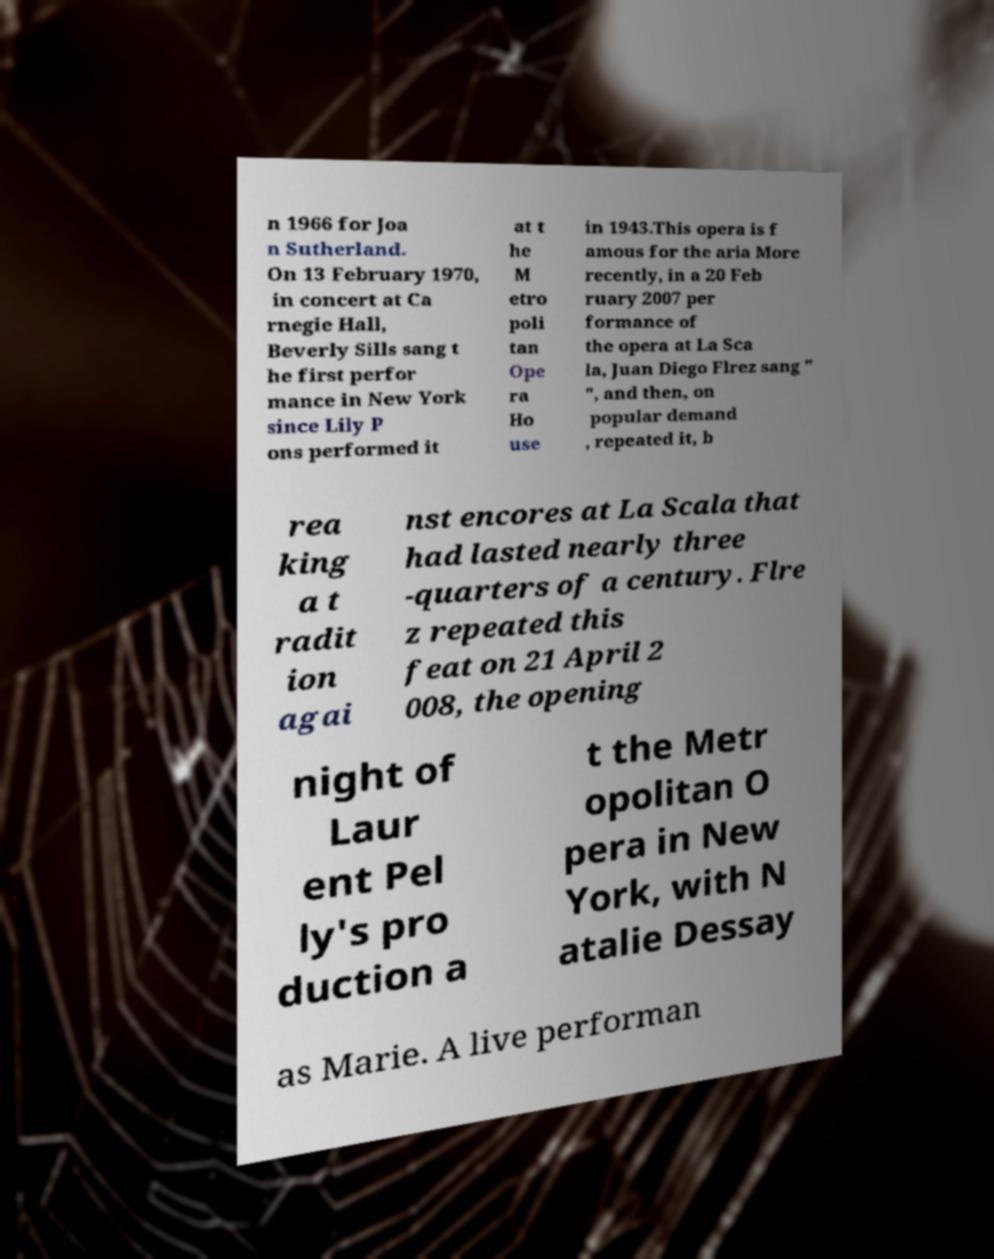For documentation purposes, I need the text within this image transcribed. Could you provide that? n 1966 for Joa n Sutherland. On 13 February 1970, in concert at Ca rnegie Hall, Beverly Sills sang t he first perfor mance in New York since Lily P ons performed it at t he M etro poli tan Ope ra Ho use in 1943.This opera is f amous for the aria More recently, in a 20 Feb ruary 2007 per formance of the opera at La Sca la, Juan Diego Flrez sang " ", and then, on popular demand , repeated it, b rea king a t radit ion agai nst encores at La Scala that had lasted nearly three -quarters of a century. Flre z repeated this feat on 21 April 2 008, the opening night of Laur ent Pel ly's pro duction a t the Metr opolitan O pera in New York, with N atalie Dessay as Marie. A live performan 